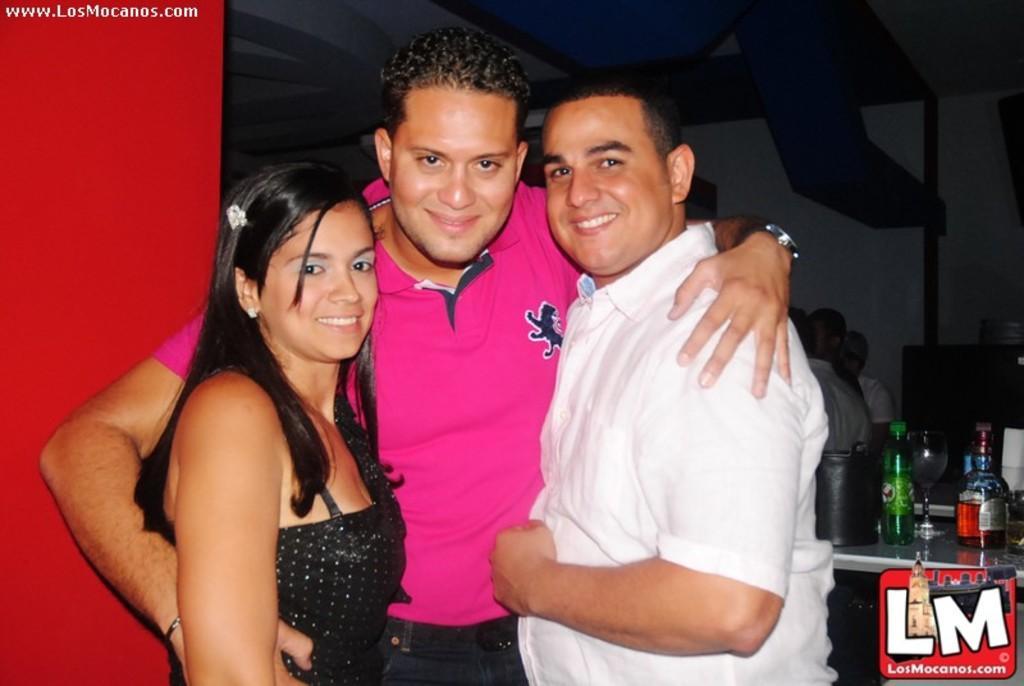Please provide a concise description of this image. This picture seems to be clicked inside the room and we can see the group of persons. On the right we can see a person wearing white color shirt, smiling and standing. In the center we can see a man wearing pink color t-shirt, smiling and standing. On the left we can see a woman wearing black color dress, smiling and standing. In the background we can see the wall, roof and we can see the bottles, glass of drink and some other objects are placed on the top of the table and we can see many other objects and we can see the watermarks on the image. 